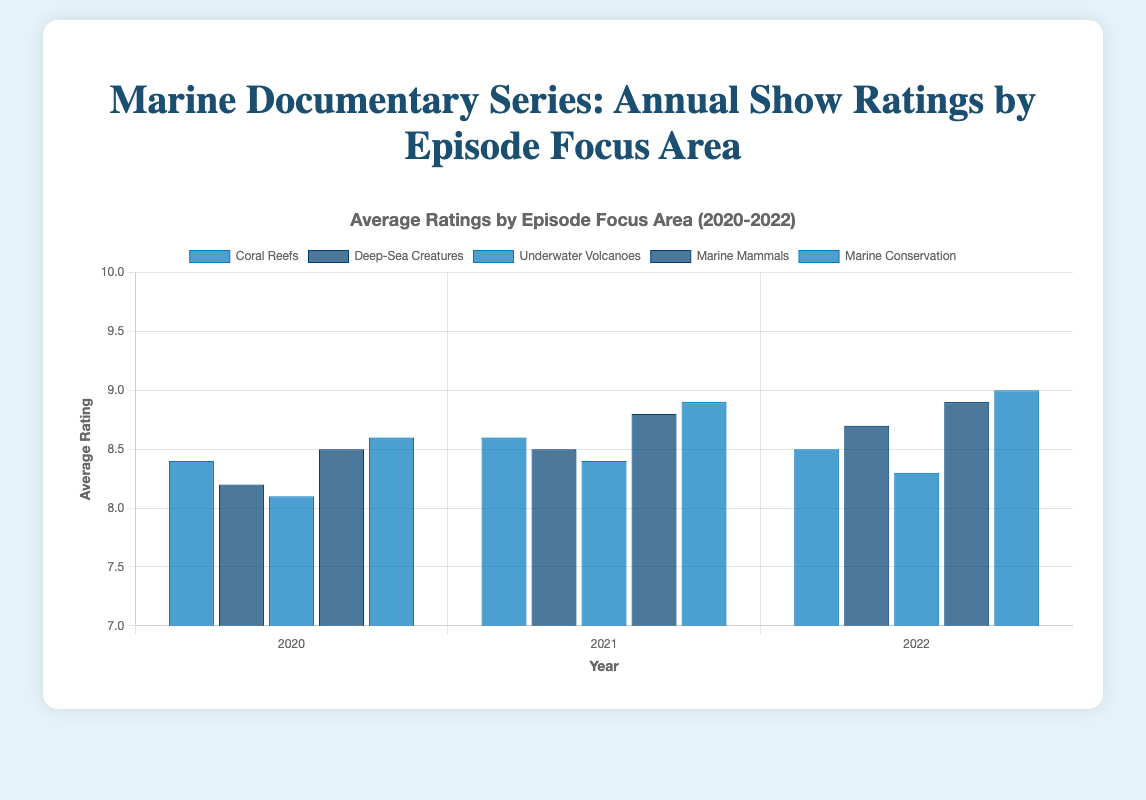What was the average rating for Marine Mammals episodes in 2021? Look for the bar corresponding to Marine Mammals in the year 2021. The height/value of the bar indicates the average rating.
Answer: 8.8 How did the average rating for Coral Reefs episodes change from 2020 to 2021? Compare the height of the Coral Reefs bar in 2020 to the height of the Coral Reefs bar in 2021. Subtract the 2020 rating (8.4) from the 2021 rating (8.6). This gives the change in average rating.
Answer: 0.2 point increase Which episode focus area had the highest average rating in 2022? Identify the tallest bar in the year 2022 across all focus areas. The label of this bar represents the episode focus area.
Answer: Marine Conservation What is the difference in the highest ratings for Underwater Volcanoes episodes between 2020 and 2021? Identify the highest rating (top data point) for Underwater Volcanoes in 2020 (8.8) and in 2021 (9.0). Subtract the 2020 rating from the 2021 rating.
Answer: 0.2 points Which episode focus area saw a consistent increase in average ratings over the three years? Look at the bars for each episode focus area and see which has increasing heights for 2020, 2021, and 2022.
Answer: Marine Conservation In 2020, which episode focus area had the lowest average rating, and what was that rating? Find the shortest bar for the year 2020. The label of this bar represents the episode focus area and the height represents the average rating.
Answer: Underwater Volcanoes with 8.1 By how much did the average rating for Deep-Sea Creatures episodes improve from 2020 to 2022? Identify the average ratings for Deep-Sea Creatures in 2020 (8.2) and in 2022 (8.7). Subtract the 2020 rating from the 2022 rating.
Answer: 0.5 points Compare the average rating of Marine Mammals episodes in 2022 with the average rating of Coral Reefs episodes in the same year. Which one is higher and by how much? Identify the average ratings for Marine Mammals (8.9) and Coral Reefs (8.5) in 2022. Subtract the Coral Reefs rating from the Marine Mammals rating to find the difference.
Answer: Marine Mammals by 0.4 points 